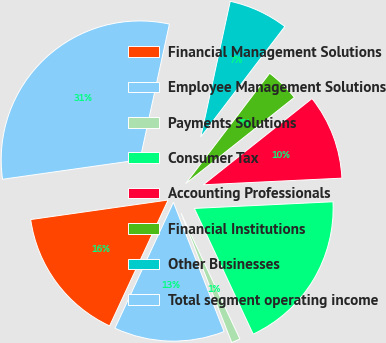<chart> <loc_0><loc_0><loc_500><loc_500><pie_chart><fcel>Financial Management Solutions<fcel>Employee Management Solutions<fcel>Payments Solutions<fcel>Consumer Tax<fcel>Accounting Professionals<fcel>Financial Institutions<fcel>Other Businesses<fcel>Total segment operating income<nl><fcel>15.83%<fcel>12.87%<fcel>1.02%<fcel>18.8%<fcel>9.91%<fcel>3.98%<fcel>6.95%<fcel>30.65%<nl></chart> 